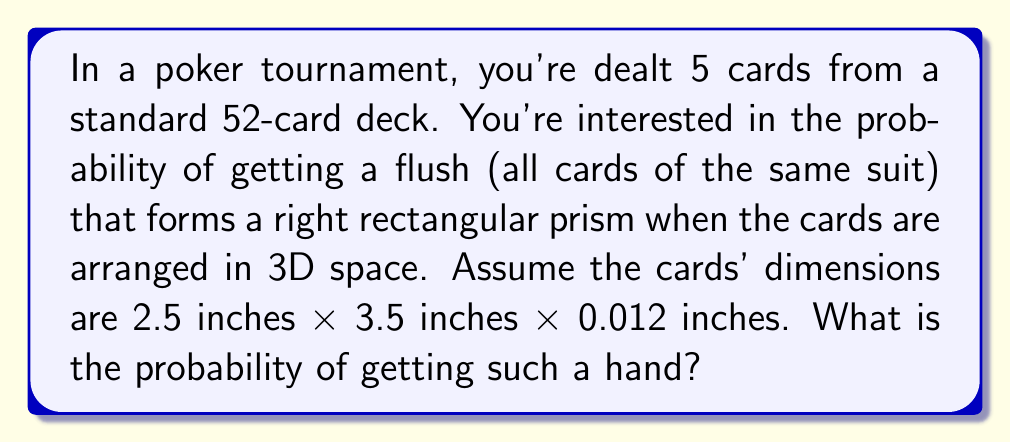Show me your answer to this math problem. To solve this problem, we need to follow these steps:

1) First, let's consider the conditions for forming a right rectangular prism:
   - We need 5 cards of the same suit (flush)
   - The cards must have values that allow them to be arranged in a 3D right rectangular prism

2) For a right rectangular prism, we need:
   - 2 cards of one value (forming the base)
   - 2 cards of another value (forming the height)
   - 1 card of a third value (forming the width)

3) The dimensions of the prism would be:
   - Base: 3.5 inches × 3.5 inches
   - Height: 2 × 2.5 inches = 5 inches
   - Width: 0.012 inches

4) Now, let's calculate the probability:
   
   a) Probability of getting a flush:
      $$P(\text{flush}) = \frac{\binom{13}{5} \times 4}{\binom{52}{5}} = \frac{1287}{649740} \approx 0.00198$$

   b) Given a flush, probability of getting the right combination:
      - Choose 2 values for the pairs: $\binom{13}{2}$
      - Choose 1 value for the single card: $\binom{11}{1}$
      - Arrange these values: $\frac{5!}{2!2!1!} = 30$

      $$P(\text{right combination} | \text{flush}) = \frac{\binom{13}{2} \times \binom{11}{1} \times 30}{\binom{13}{5}} = \frac{78 \times 11 \times 30}{1287} = \frac{25740}{1287} = 20$$

5) The final probability is the product of these two probabilities:

   $$P(\text{flush forming prism}) = P(\text{flush}) \times P(\text{right combination} | \text{flush})$$
   $$= \frac{1287}{649740} \times \frac{25740}{1287} = \frac{25740}{649740} = \frac{429}{10829} \approx 0.0396$$
Answer: $\frac{429}{10829}$ or approximately 0.0396 (3.96%) 